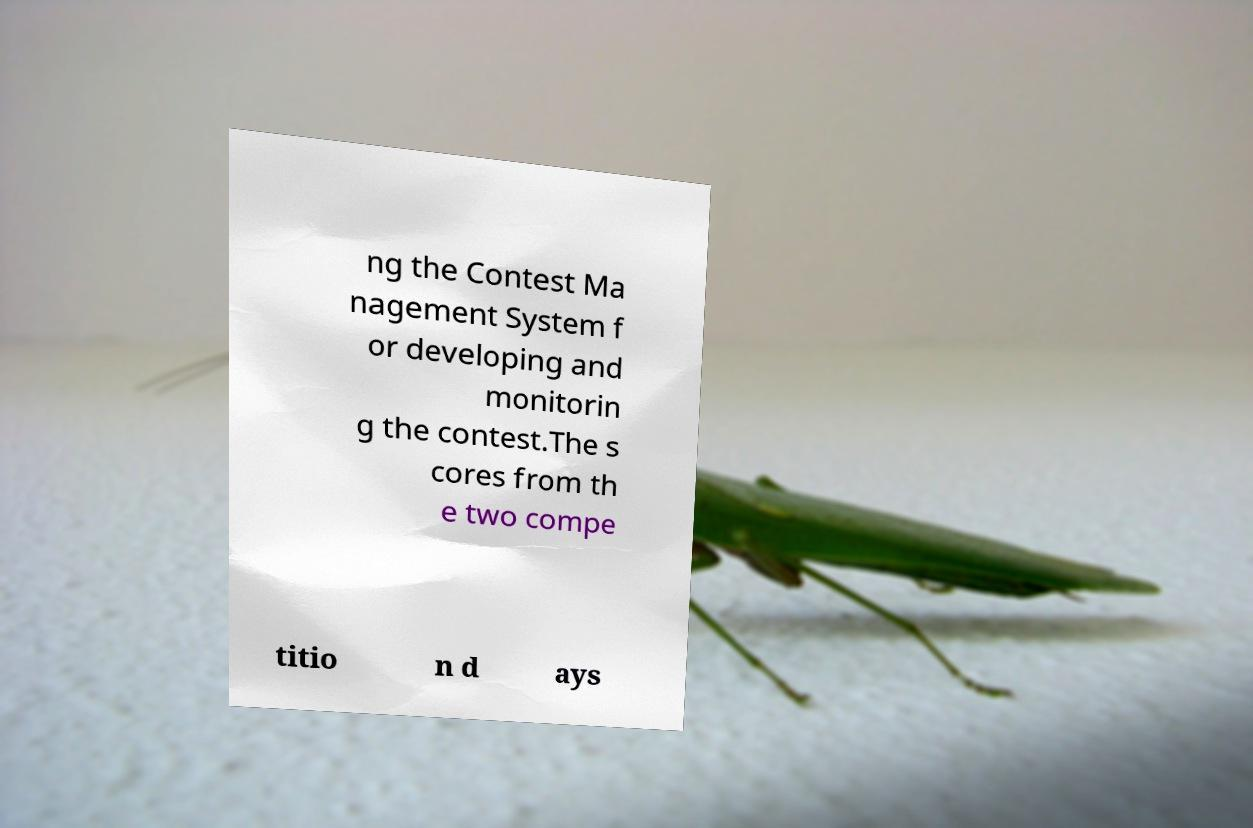Please read and relay the text visible in this image. What does it say? ng the Contest Ma nagement System f or developing and monitorin g the contest.The s cores from th e two compe titio n d ays 